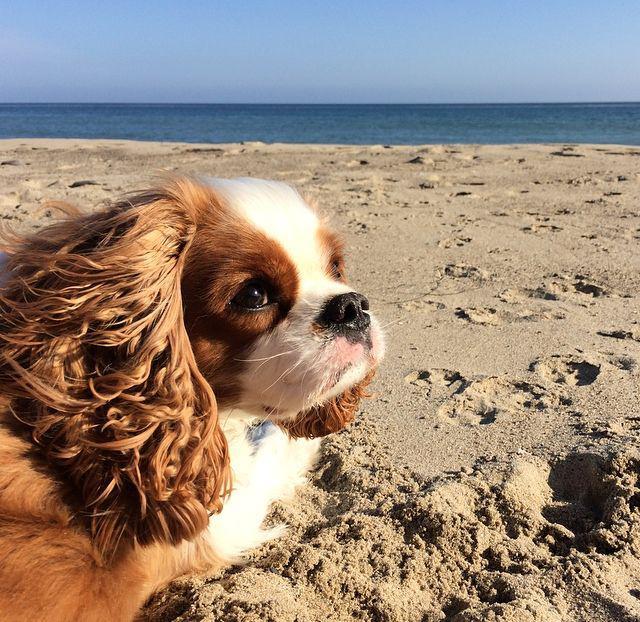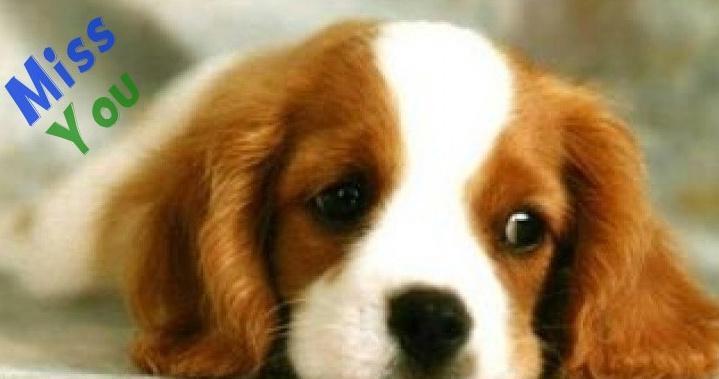The first image is the image on the left, the second image is the image on the right. Assess this claim about the two images: "There are no more than four dogs.". Correct or not? Answer yes or no. Yes. The first image is the image on the left, the second image is the image on the right. Examine the images to the left and right. Is the description "One of the puppies is laying the side of its head against a blanket." accurate? Answer yes or no. No. 